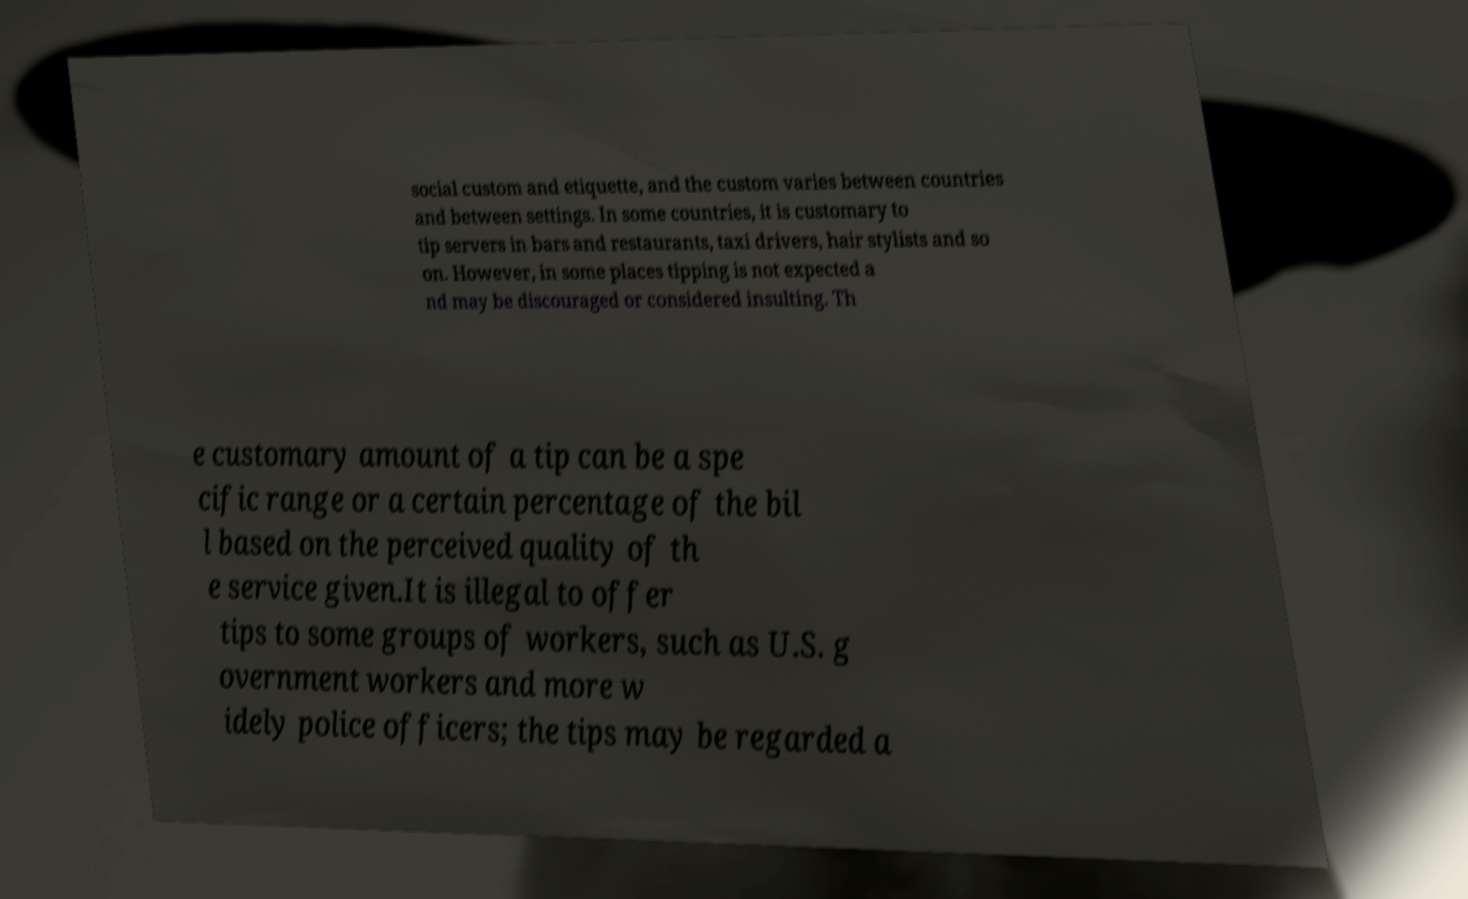What messages or text are displayed in this image? I need them in a readable, typed format. social custom and etiquette, and the custom varies between countries and between settings. In some countries, it is customary to tip servers in bars and restaurants, taxi drivers, hair stylists and so on. However, in some places tipping is not expected a nd may be discouraged or considered insulting. Th e customary amount of a tip can be a spe cific range or a certain percentage of the bil l based on the perceived quality of th e service given.It is illegal to offer tips to some groups of workers, such as U.S. g overnment workers and more w idely police officers; the tips may be regarded a 